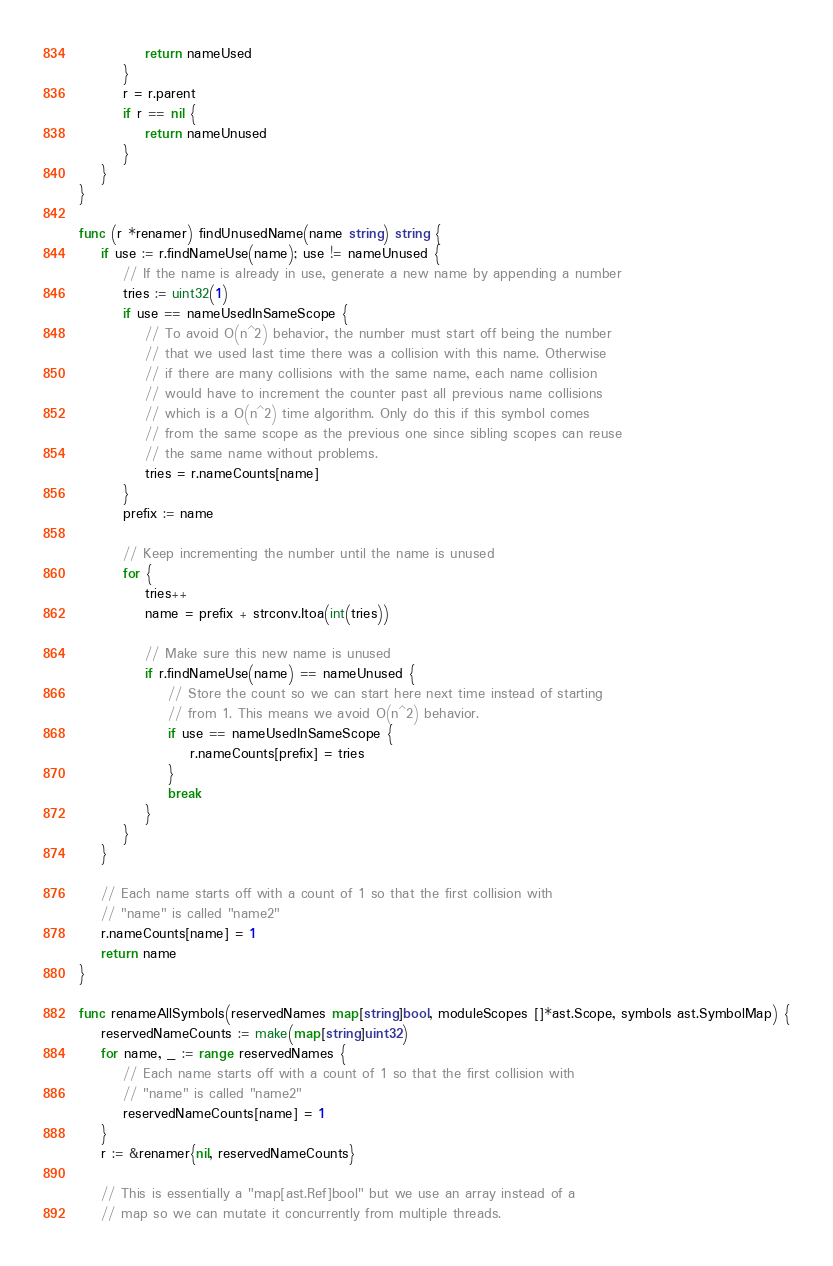<code> <loc_0><loc_0><loc_500><loc_500><_Go_>			return nameUsed
		}
		r = r.parent
		if r == nil {
			return nameUnused
		}
	}
}

func (r *renamer) findUnusedName(name string) string {
	if use := r.findNameUse(name); use != nameUnused {
		// If the name is already in use, generate a new name by appending a number
		tries := uint32(1)
		if use == nameUsedInSameScope {
			// To avoid O(n^2) behavior, the number must start off being the number
			// that we used last time there was a collision with this name. Otherwise
			// if there are many collisions with the same name, each name collision
			// would have to increment the counter past all previous name collisions
			// which is a O(n^2) time algorithm. Only do this if this symbol comes
			// from the same scope as the previous one since sibling scopes can reuse
			// the same name without problems.
			tries = r.nameCounts[name]
		}
		prefix := name

		// Keep incrementing the number until the name is unused
		for {
			tries++
			name = prefix + strconv.Itoa(int(tries))

			// Make sure this new name is unused
			if r.findNameUse(name) == nameUnused {
				// Store the count so we can start here next time instead of starting
				// from 1. This means we avoid O(n^2) behavior.
				if use == nameUsedInSameScope {
					r.nameCounts[prefix] = tries
				}
				break
			}
		}
	}

	// Each name starts off with a count of 1 so that the first collision with
	// "name" is called "name2"
	r.nameCounts[name] = 1
	return name
}

func renameAllSymbols(reservedNames map[string]bool, moduleScopes []*ast.Scope, symbols ast.SymbolMap) {
	reservedNameCounts := make(map[string]uint32)
	for name, _ := range reservedNames {
		// Each name starts off with a count of 1 so that the first collision with
		// "name" is called "name2"
		reservedNameCounts[name] = 1
	}
	r := &renamer{nil, reservedNameCounts}

	// This is essentially a "map[ast.Ref]bool" but we use an array instead of a
	// map so we can mutate it concurrently from multiple threads.</code> 